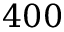<formula> <loc_0><loc_0><loc_500><loc_500>4 0 0</formula> 